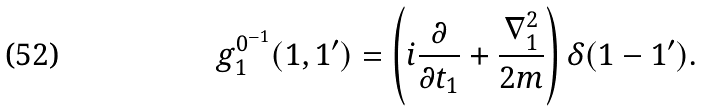<formula> <loc_0><loc_0><loc_500><loc_500>g _ { 1 } ^ { 0 ^ { - 1 } } ( 1 , 1 ^ { \prime } ) = \left ( i \frac { \partial } { \partial t _ { 1 } } + \frac { \nabla _ { 1 } ^ { 2 } } { 2 m } \right ) \delta ( 1 - 1 ^ { \prime } ) .</formula> 